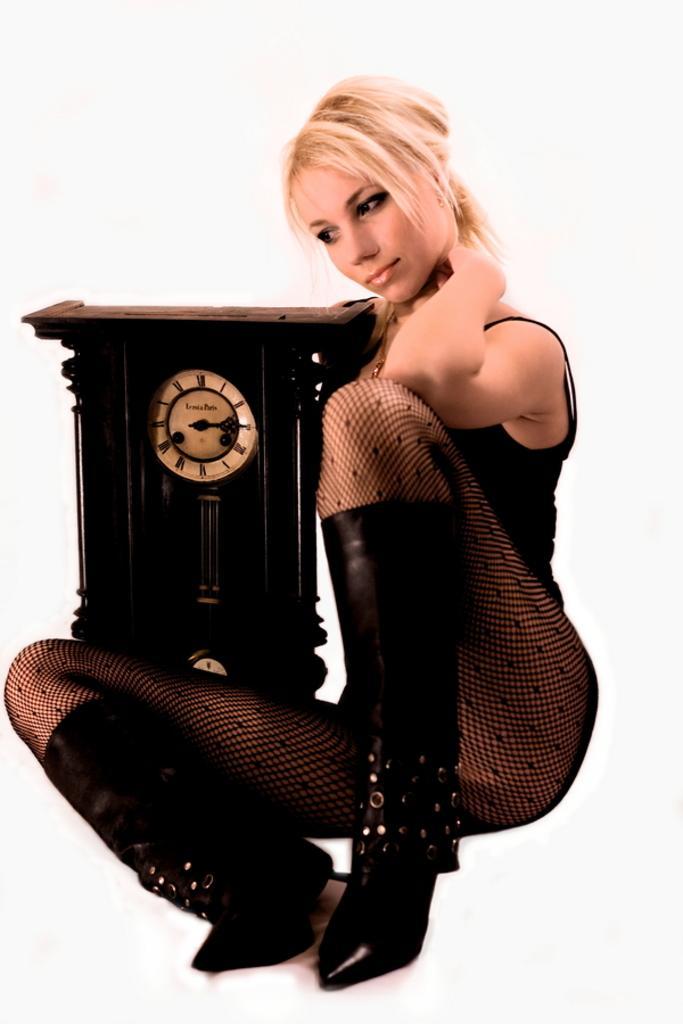Can you describe this image briefly? In this picture there is a woman sitting beside the wooden clock and looking on the left side. Behind there is a white background. 